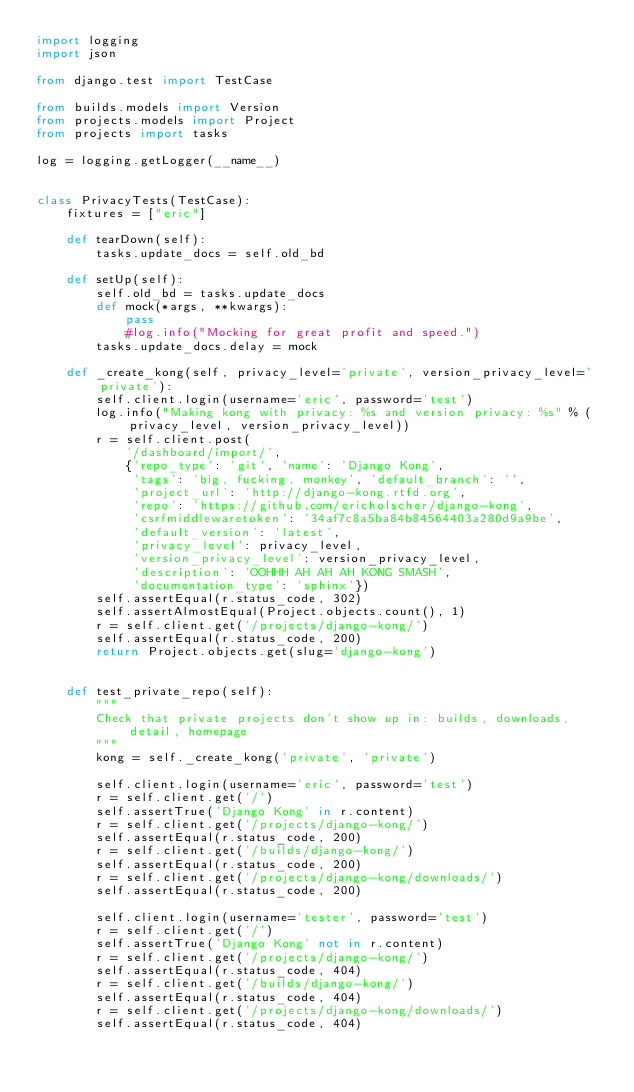<code> <loc_0><loc_0><loc_500><loc_500><_Python_>import logging
import json

from django.test import TestCase

from builds.models import Version
from projects.models import Project
from projects import tasks

log = logging.getLogger(__name__)


class PrivacyTests(TestCase):
    fixtures = ["eric"]

    def tearDown(self):
        tasks.update_docs = self.old_bd

    def setUp(self):
        self.old_bd = tasks.update_docs
        def mock(*args, **kwargs):
            pass
            #log.info("Mocking for great profit and speed.")
        tasks.update_docs.delay = mock

    def _create_kong(self, privacy_level='private', version_privacy_level='private'):
        self.client.login(username='eric', password='test')
        log.info("Making kong with privacy: %s and version privacy: %s" % (privacy_level, version_privacy_level))
        r = self.client.post(
            '/dashboard/import/',
            {'repo_type': 'git', 'name': 'Django Kong',
             'tags': 'big, fucking, monkey', 'default_branch': '',
             'project_url': 'http://django-kong.rtfd.org',
             'repo': 'https://github.com/ericholscher/django-kong',
             'csrfmiddlewaretoken': '34af7c8a5ba84b84564403a280d9a9be',
             'default_version': 'latest',
             'privacy_level': privacy_level,
             'version_privacy_level': version_privacy_level,
             'description': 'OOHHH AH AH AH KONG SMASH',
             'documentation_type': 'sphinx'})
        self.assertEqual(r.status_code, 302)
        self.assertAlmostEqual(Project.objects.count(), 1)
        r = self.client.get('/projects/django-kong/')
        self.assertEqual(r.status_code, 200)
        return Project.objects.get(slug='django-kong')


    def test_private_repo(self):
        """
        Check that private projects don't show up in: builds, downloads, detail, homepage
        """
        kong = self._create_kong('private', 'private')

        self.client.login(username='eric', password='test')
        r = self.client.get('/')
        self.assertTrue('Django Kong' in r.content)
        r = self.client.get('/projects/django-kong/')
        self.assertEqual(r.status_code, 200)
        r = self.client.get('/builds/django-kong/')
        self.assertEqual(r.status_code, 200)
        r = self.client.get('/projects/django-kong/downloads/')
        self.assertEqual(r.status_code, 200)

        self.client.login(username='tester', password='test')
        r = self.client.get('/')
        self.assertTrue('Django Kong' not in r.content)
        r = self.client.get('/projects/django-kong/')
        self.assertEqual(r.status_code, 404)
        r = self.client.get('/builds/django-kong/')
        self.assertEqual(r.status_code, 404)
        r = self.client.get('/projects/django-kong/downloads/')
        self.assertEqual(r.status_code, 404)

</code> 